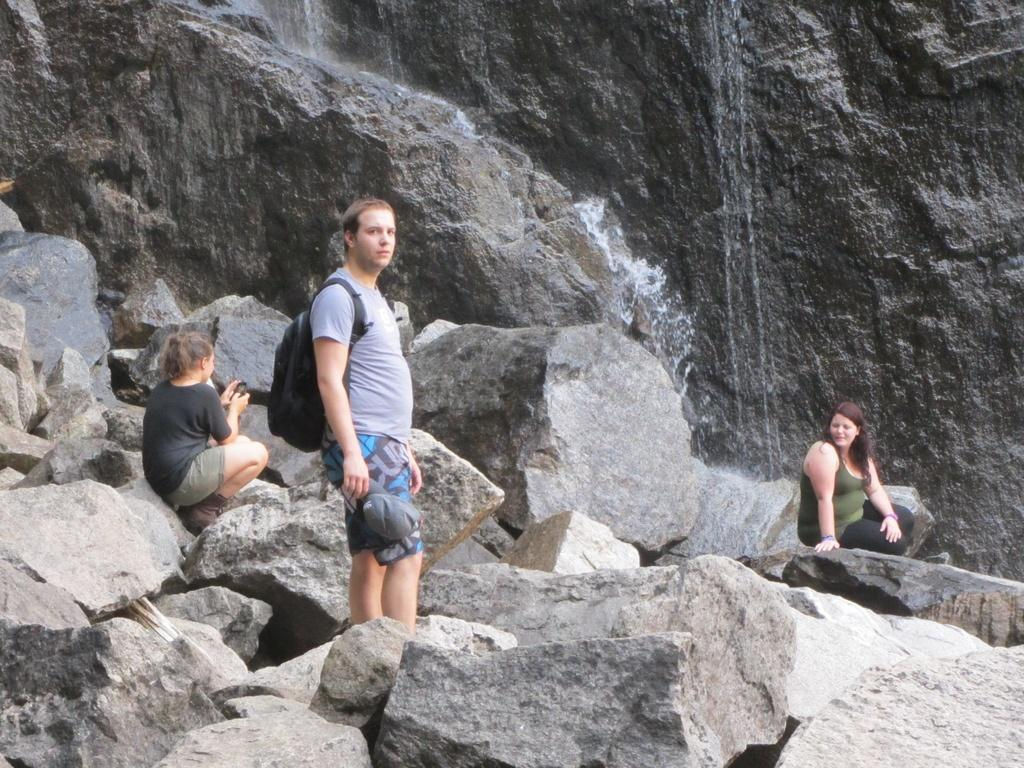How many people are in the image? There are three people in the image. What are the positions of the people in the image? One person is standing on a rock, and two people are sitting on rocks. What can be seen in the background of the image? There is water visible on the rocks in the background. What type of number is being used to count the people in the image? The question is unclear and seems to be unrelated to the image. The image does not depict any numbers or counting methods. 